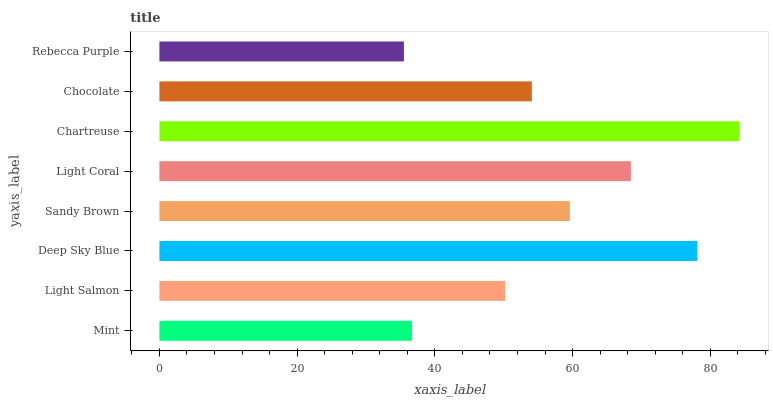Is Rebecca Purple the minimum?
Answer yes or no. Yes. Is Chartreuse the maximum?
Answer yes or no. Yes. Is Light Salmon the minimum?
Answer yes or no. No. Is Light Salmon the maximum?
Answer yes or no. No. Is Light Salmon greater than Mint?
Answer yes or no. Yes. Is Mint less than Light Salmon?
Answer yes or no. Yes. Is Mint greater than Light Salmon?
Answer yes or no. No. Is Light Salmon less than Mint?
Answer yes or no. No. Is Sandy Brown the high median?
Answer yes or no. Yes. Is Chocolate the low median?
Answer yes or no. Yes. Is Chocolate the high median?
Answer yes or no. No. Is Mint the low median?
Answer yes or no. No. 